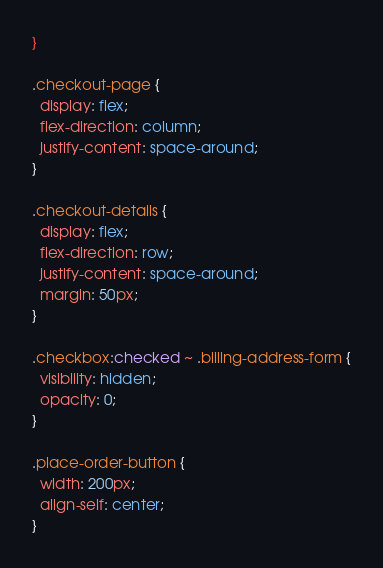Convert code to text. <code><loc_0><loc_0><loc_500><loc_500><_CSS_>}

.checkout-page {
  display: flex;
  flex-direction: column;
  justify-content: space-around;
}

.checkout-details {
  display: flex;
  flex-direction: row;
  justify-content: space-around;
  margin: 50px;
}

.checkbox:checked ~ .billing-address-form {
  visibility: hidden;
  opacity: 0;
}

.place-order-button {
  width: 200px;
  align-self: center;
}
</code> 